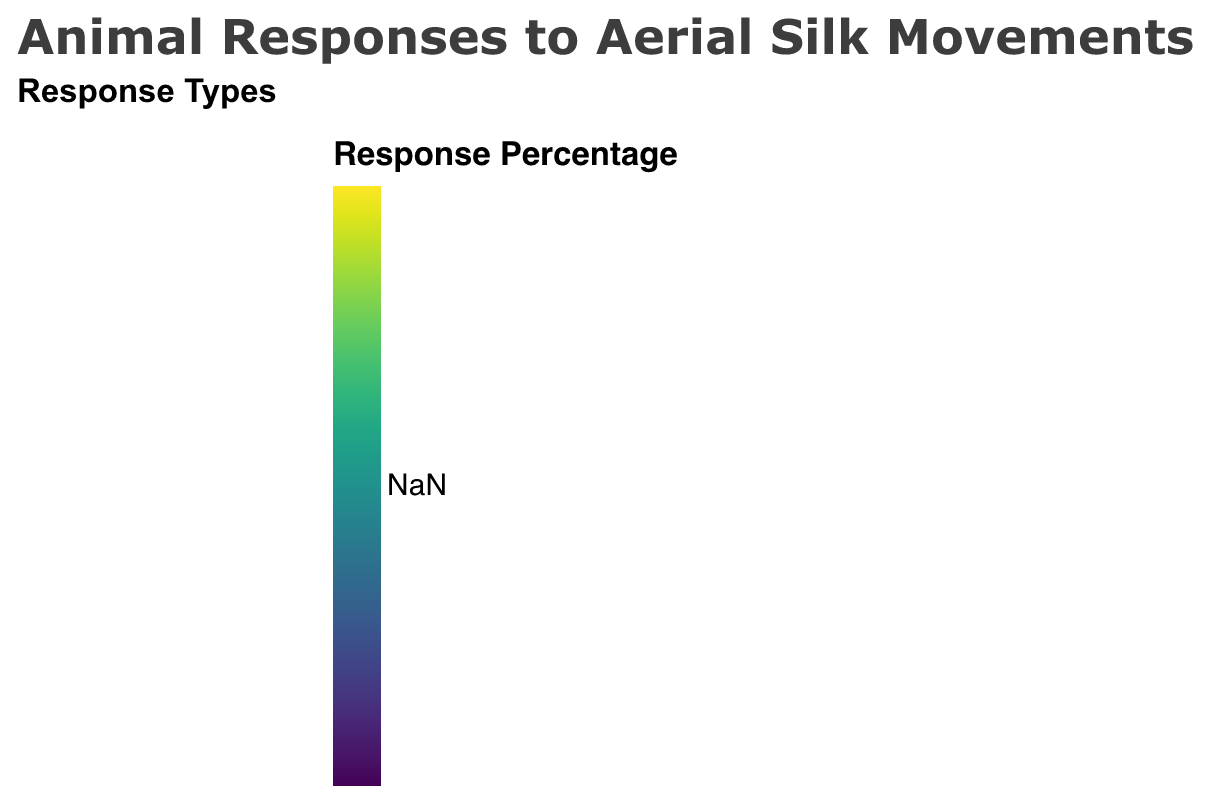What's the title of this heatmap? The title of the plot is located at the top and it is clearly written in a larger font compared to other text elements.
Answer: Animal Responses to Aerial Silk Movements Which animal species shows the highest positive response at 4 weeks of training? We examine the heatmap under the "Positive Response" facet and look at the data for 4 weeks of training. The Parrots have a response value of 90, which is higher than any other species.
Answer: Parrots How does the neutral response of Cats change from 1 week to 4 weeks of training? We observe the "Neutral Response" facet. For Cats, the response value starts at 40 for 1 week, decreases to 30 for 2 weeks, and further decreases to 20 for 4 weeks.
Answer: Decreases Between Dogs and Ducks, which species shows a greater increase in positive response from 2 weeks to 4 weeks of training? In the "Positive Response" facet, Dogs improve from 70 to 85, a difference of 15. Ducks improve from 55 to 75, a difference of 20. Thus, Ducks show a greater increase.
Answer: Ducks Which response type has the least variation in values across all species and training durations? We compare the spread of values for "Positive Response," "Neutral Response," and "Negative Response." "Negative Response" values show the least variation, ranging from 2 to 30, compared to broader ranges in the other two.
Answer: Negative Response What is the positive response percentage for Ferrets at 2 weeks of training? Referring to the "Positive Response" facet and the cell corresponding to Ferrets and 2 weeks, the response value is 60.
Answer: 60 Which species shows the smallest neutral response at 1 week of training? In the "Neutral Response" facet, we look at the 1-week training column. Parrots show the smallest value of 30.
Answer: Parrots Compare the negative response rates of Rabbits and Cats after 4 weeks of training. In the "Negative Response" facet, for 4 weeks of training, Rabbits have a response value of 10 and Cats also have the same value of 10.
Answer: Equal What's the difference between the positive response rates of Dogs and Ferrets at 4 weeks of training? In the "Positive Response" facet, Dogs have a value of 85 and Ferrets have a value of 80 for 4 weeks. Subtracting these values gives 5.
Answer: 5 Which species shows the greatest overall improvement in positive response from 1 to 4 weeks of training? We calculate the difference between 1 week and 4 weeks in the "Positive Response" facet for each species. Parrots improve from 60 to 90, an increase of 30, the largest improvement among species.
Answer: Parrots 